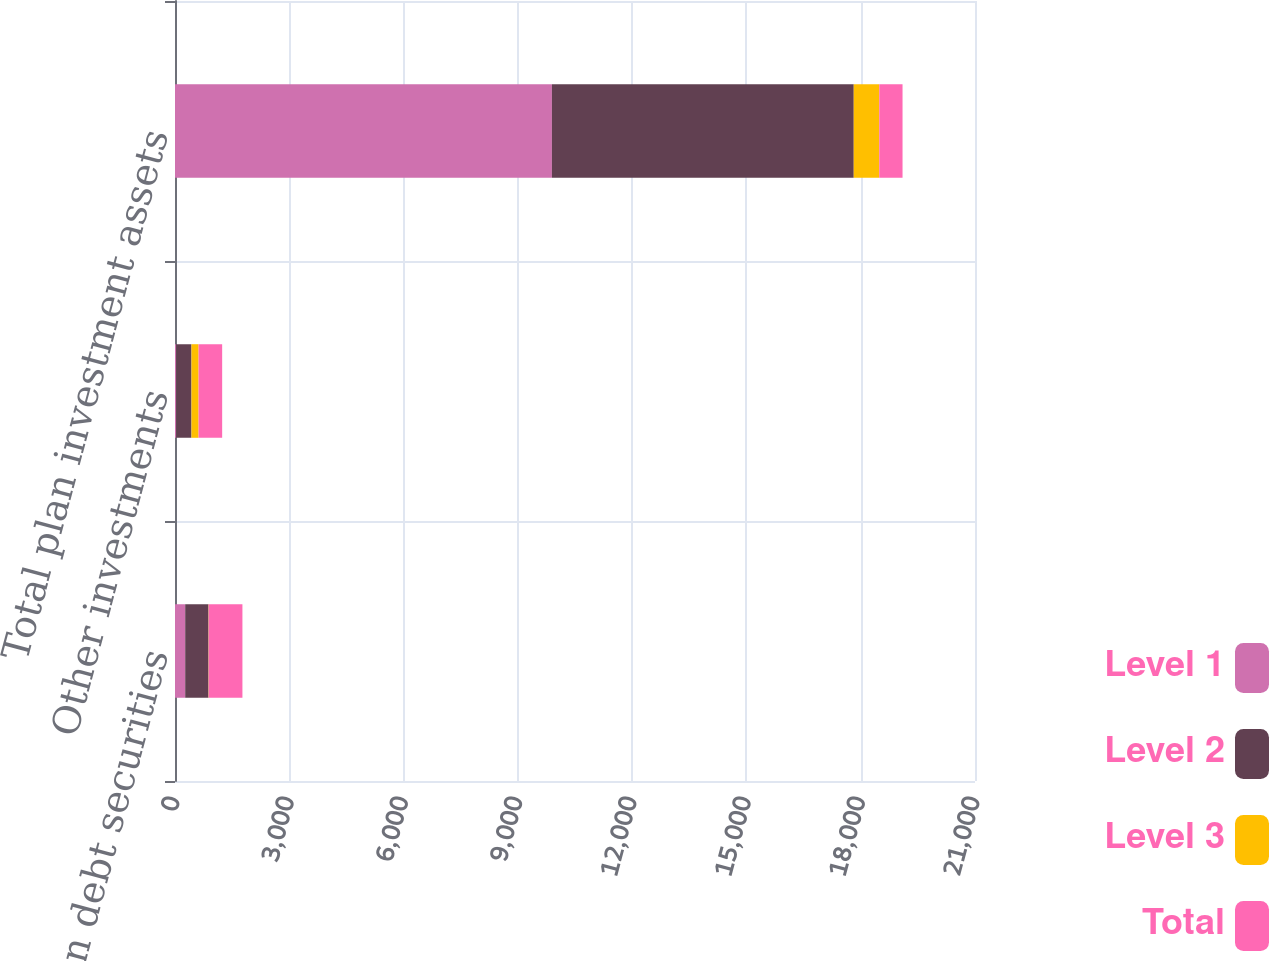Convert chart to OTSL. <chart><loc_0><loc_0><loc_500><loc_500><stacked_bar_chart><ecel><fcel>Foreign debt securities<fcel>Other investments<fcel>Total plan investment assets<nl><fcel>Level 1<fcel>268<fcel>30<fcel>9894<nl><fcel>Level 2<fcel>611<fcel>402<fcel>7923<nl><fcel>Level 3<fcel>6<fcel>187<fcel>670<nl><fcel>Total<fcel>885<fcel>619<fcel>611<nl></chart> 